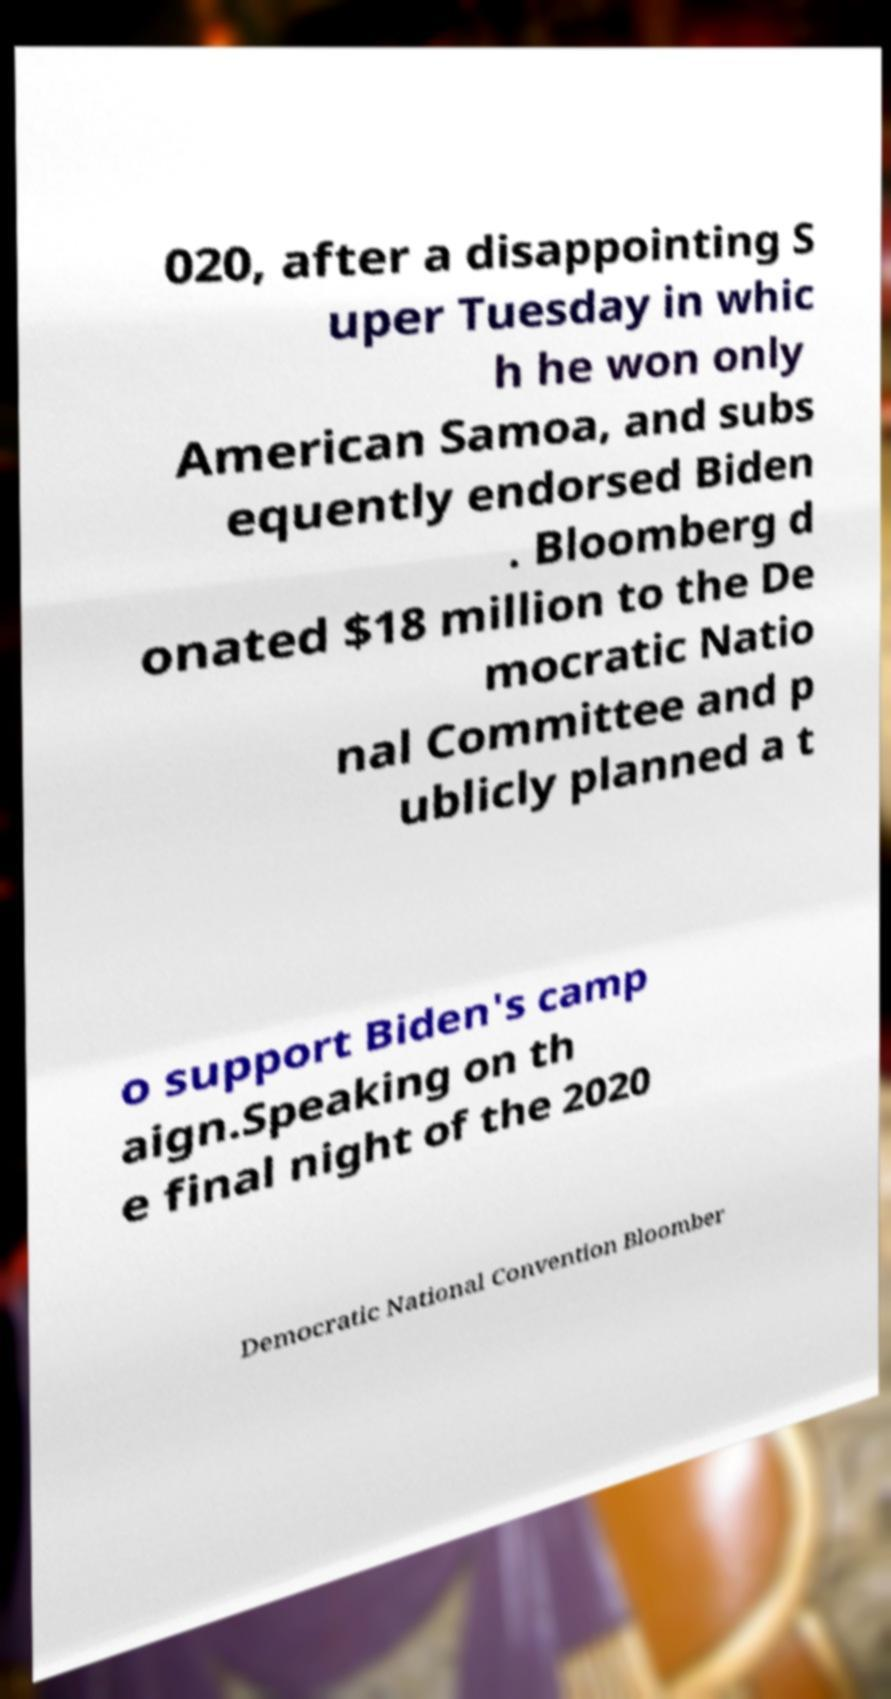Please read and relay the text visible in this image. What does it say? 020, after a disappointing S uper Tuesday in whic h he won only American Samoa, and subs equently endorsed Biden . Bloomberg d onated $18 million to the De mocratic Natio nal Committee and p ublicly planned a t o support Biden's camp aign.Speaking on th e final night of the 2020 Democratic National Convention Bloomber 